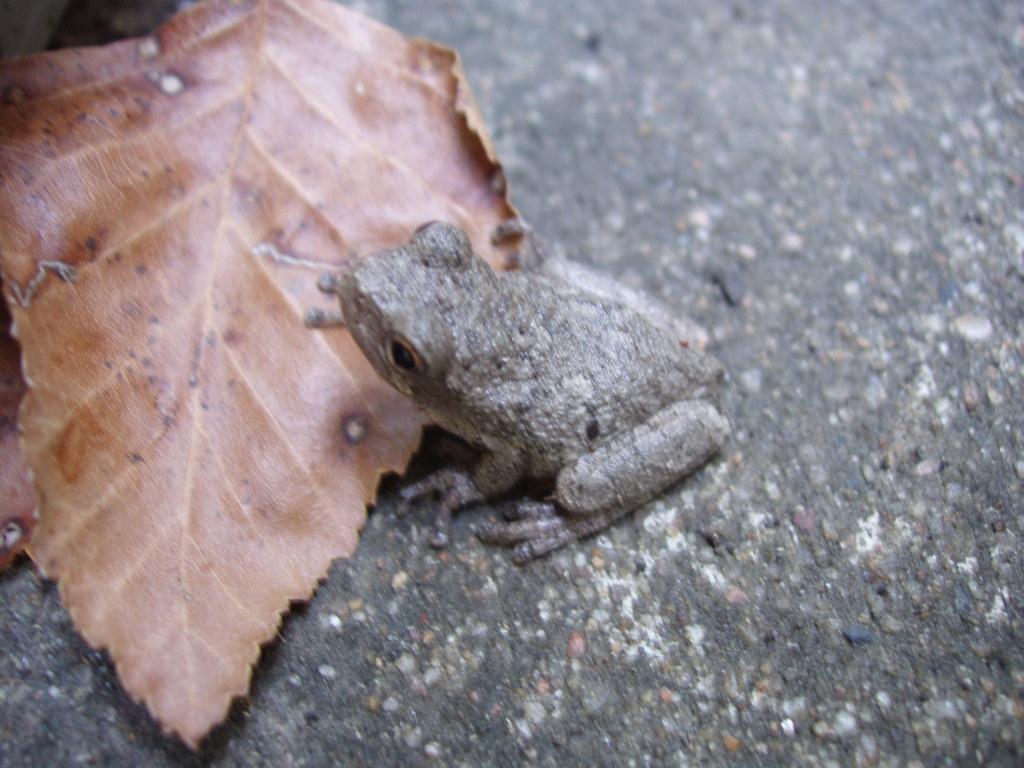Describe this image in one or two sentences. In the image we can see a frog. Behind the frog there is leaf. 